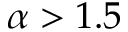<formula> <loc_0><loc_0><loc_500><loc_500>\alpha > 1 . 5</formula> 